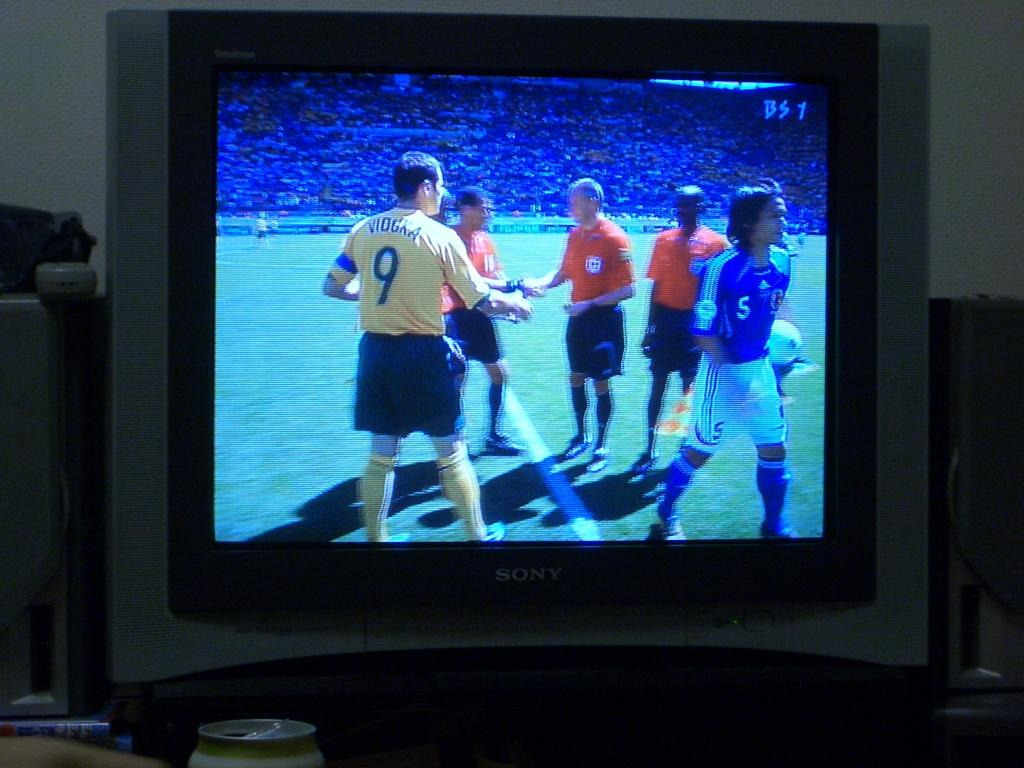<image>
Offer a succinct explanation of the picture presented. The player with the yellow jersey is number 9 